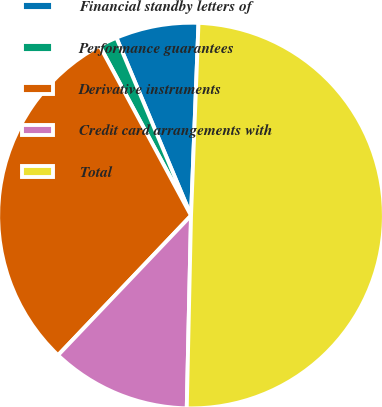Convert chart. <chart><loc_0><loc_0><loc_500><loc_500><pie_chart><fcel>Financial standby letters of<fcel>Performance guarantees<fcel>Derivative instruments<fcel>Credit card arrangements with<fcel>Total<nl><fcel>6.94%<fcel>1.54%<fcel>30.03%<fcel>11.76%<fcel>49.74%<nl></chart> 